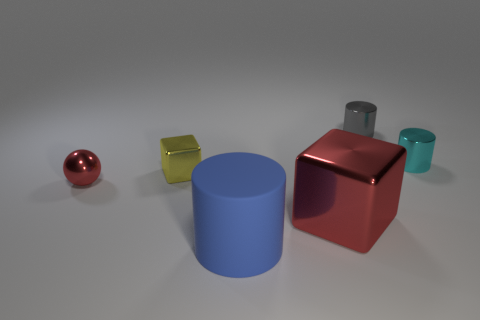There is a cylinder that is both behind the small red ball and to the left of the small cyan metal cylinder; what color is it?
Give a very brief answer. Gray. There is a tiny thing that is on the right side of the tiny gray metal cylinder; does it have the same shape as the red object that is right of the metallic sphere?
Your answer should be very brief. No. There is a tiny cylinder that is on the left side of the cyan shiny cylinder; what material is it?
Make the answer very short. Metal. The block that is the same color as the tiny sphere is what size?
Make the answer very short. Large. How many objects are large things behind the large blue thing or tiny cyan cylinders?
Offer a terse response. 2. Are there the same number of small shiny things behind the small gray thing and large red matte balls?
Make the answer very short. Yes. Do the red cube and the yellow object have the same size?
Offer a terse response. No. What is the color of the block that is the same size as the red ball?
Ensure brevity in your answer.  Yellow. There is a red metal sphere; is its size the same as the red thing right of the big rubber cylinder?
Provide a short and direct response. No. What number of other matte objects are the same color as the large matte thing?
Your answer should be very brief. 0. 